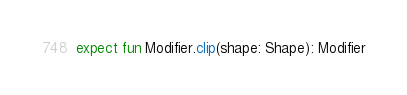Convert code to text. <code><loc_0><loc_0><loc_500><loc_500><_Kotlin_>expect fun Modifier.clip(shape: Shape): Modifier
</code> 